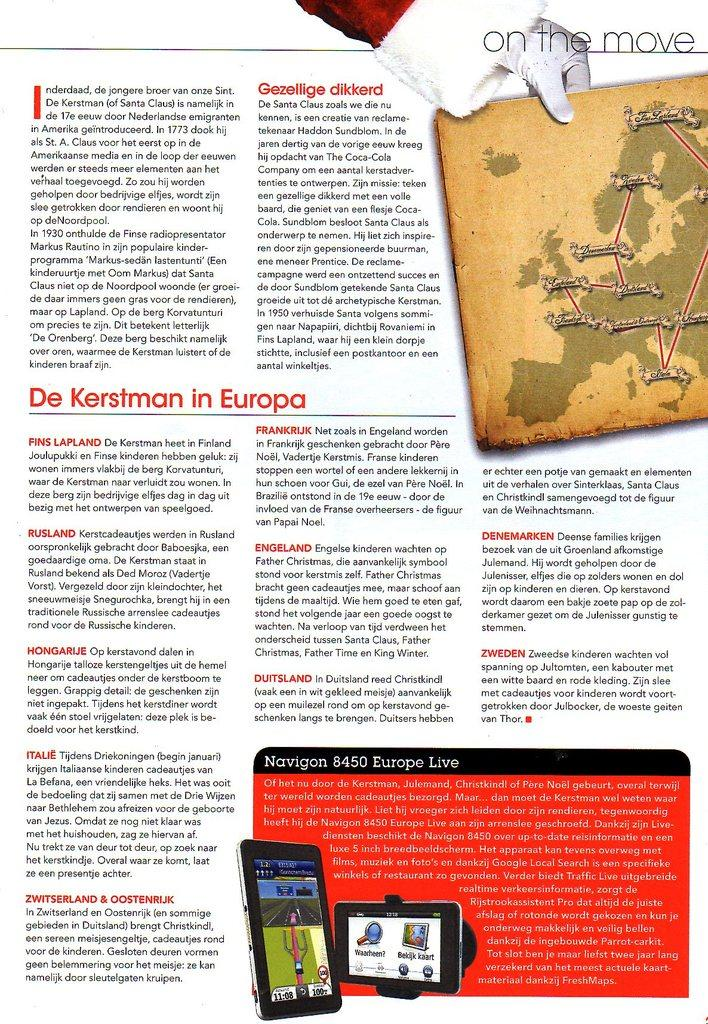<image>
Relay a brief, clear account of the picture shown. a page of text from a magazine section ON THE MOVE 